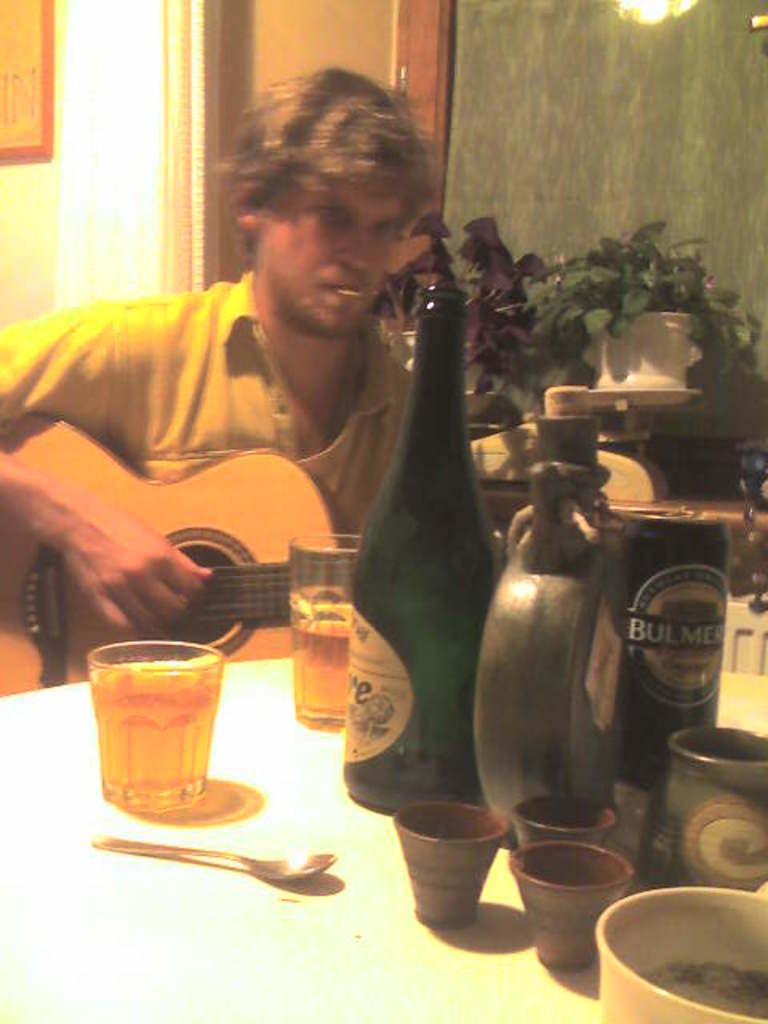How would you summarize this image in a sentence or two? A man is sitting and playing guitar. In front of him there is a table. On the table there are some bottles, glasses, spoon and bowl. And to the left him there are plants. And behind him there is a door. 